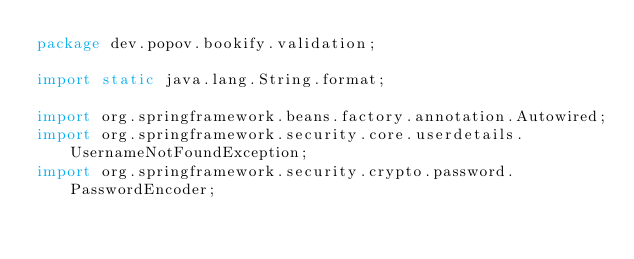<code> <loc_0><loc_0><loc_500><loc_500><_Java_>package dev.popov.bookify.validation;

import static java.lang.String.format;

import org.springframework.beans.factory.annotation.Autowired;
import org.springframework.security.core.userdetails.UsernameNotFoundException;
import org.springframework.security.crypto.password.PasswordEncoder;</code> 